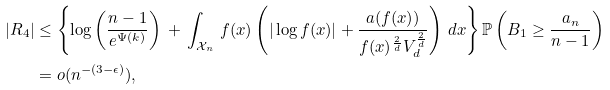Convert formula to latex. <formula><loc_0><loc_0><loc_500><loc_500>| R _ { 4 } | & \leq \left \{ \log \left ( \frac { n - 1 } { e ^ { \Psi ( k ) } } \right ) \, + \, \int _ { \mathcal { X } _ { n } } \, f ( x ) \left ( | \log f ( x ) | + \frac { a ( f ( x ) ) } { f ( x ) ^ { \frac { 2 } { d } } V _ { d } ^ { \frac { 2 } { d } } } \right ) \, d x \right \} \mathbb { P } \left ( B _ { 1 } \geq \frac { a _ { n } } { n - 1 } \right ) \\ & = o ( n ^ { - ( 3 - \epsilon ) } ) ,</formula> 